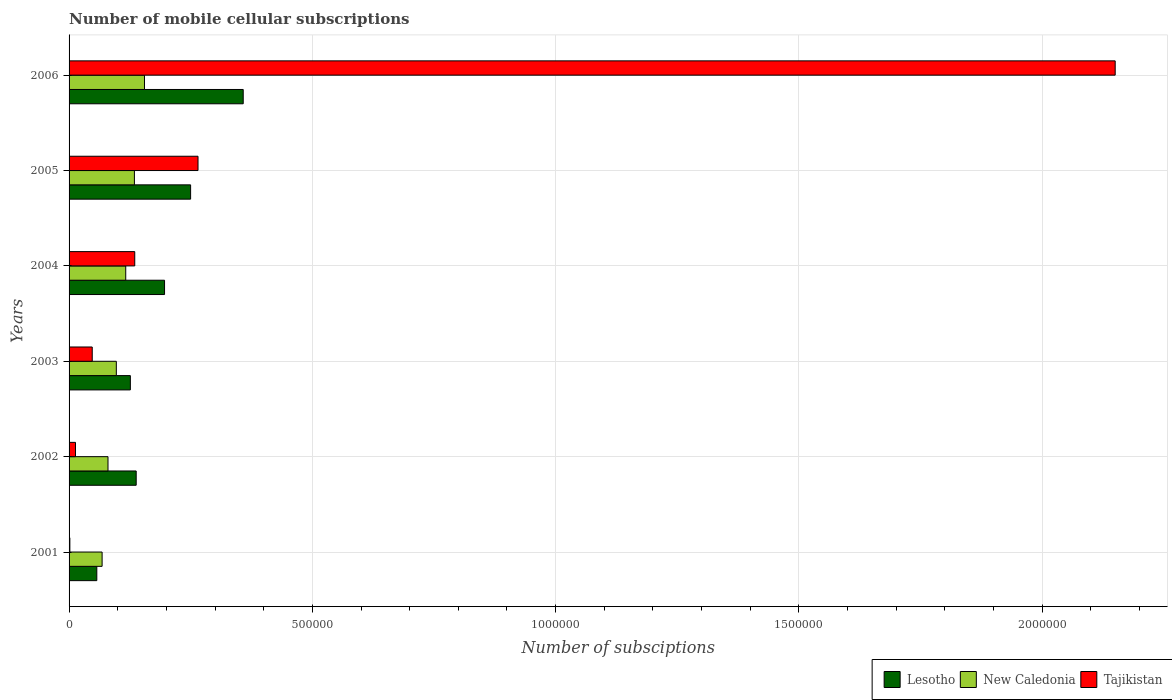How many different coloured bars are there?
Your response must be concise. 3. In how many cases, is the number of bars for a given year not equal to the number of legend labels?
Make the answer very short. 0. What is the number of mobile cellular subscriptions in New Caledonia in 2005?
Provide a succinct answer. 1.34e+05. Across all years, what is the maximum number of mobile cellular subscriptions in Tajikistan?
Provide a short and direct response. 2.15e+06. Across all years, what is the minimum number of mobile cellular subscriptions in Tajikistan?
Provide a short and direct response. 1630. In which year was the number of mobile cellular subscriptions in Tajikistan maximum?
Keep it short and to the point. 2006. What is the total number of mobile cellular subscriptions in Lesotho in the graph?
Keep it short and to the point. 1.12e+06. What is the difference between the number of mobile cellular subscriptions in Tajikistan in 2005 and that in 2006?
Provide a succinct answer. -1.88e+06. What is the difference between the number of mobile cellular subscriptions in New Caledonia in 2003 and the number of mobile cellular subscriptions in Lesotho in 2002?
Give a very brief answer. -4.08e+04. What is the average number of mobile cellular subscriptions in Tajikistan per year?
Your answer should be compact. 4.35e+05. In the year 2006, what is the difference between the number of mobile cellular subscriptions in Tajikistan and number of mobile cellular subscriptions in New Caledonia?
Provide a short and direct response. 2.00e+06. What is the ratio of the number of mobile cellular subscriptions in Lesotho in 2001 to that in 2002?
Keep it short and to the point. 0.41. Is the number of mobile cellular subscriptions in New Caledonia in 2002 less than that in 2004?
Ensure brevity in your answer.  Yes. What is the difference between the highest and the second highest number of mobile cellular subscriptions in Lesotho?
Make the answer very short. 1.08e+05. What is the difference between the highest and the lowest number of mobile cellular subscriptions in Tajikistan?
Offer a terse response. 2.15e+06. In how many years, is the number of mobile cellular subscriptions in New Caledonia greater than the average number of mobile cellular subscriptions in New Caledonia taken over all years?
Your response must be concise. 3. Is the sum of the number of mobile cellular subscriptions in Lesotho in 2002 and 2004 greater than the maximum number of mobile cellular subscriptions in Tajikistan across all years?
Keep it short and to the point. No. What does the 1st bar from the top in 2006 represents?
Your answer should be very brief. Tajikistan. What does the 1st bar from the bottom in 2002 represents?
Offer a terse response. Lesotho. Is it the case that in every year, the sum of the number of mobile cellular subscriptions in Lesotho and number of mobile cellular subscriptions in New Caledonia is greater than the number of mobile cellular subscriptions in Tajikistan?
Ensure brevity in your answer.  No. How many bars are there?
Your response must be concise. 18. How many years are there in the graph?
Provide a short and direct response. 6. What is the difference between two consecutive major ticks on the X-axis?
Provide a succinct answer. 5.00e+05. Does the graph contain any zero values?
Ensure brevity in your answer.  No. How many legend labels are there?
Provide a short and direct response. 3. How are the legend labels stacked?
Your response must be concise. Horizontal. What is the title of the graph?
Provide a succinct answer. Number of mobile cellular subscriptions. What is the label or title of the X-axis?
Make the answer very short. Number of subsciptions. What is the Number of subsciptions in Lesotho in 2001?
Keep it short and to the point. 5.70e+04. What is the Number of subsciptions in New Caledonia in 2001?
Your answer should be very brief. 6.79e+04. What is the Number of subsciptions in Tajikistan in 2001?
Your answer should be very brief. 1630. What is the Number of subsciptions in Lesotho in 2002?
Give a very brief answer. 1.38e+05. What is the Number of subsciptions of Tajikistan in 2002?
Ensure brevity in your answer.  1.32e+04. What is the Number of subsciptions in Lesotho in 2003?
Keep it short and to the point. 1.26e+05. What is the Number of subsciptions of New Caledonia in 2003?
Your answer should be very brief. 9.71e+04. What is the Number of subsciptions of Tajikistan in 2003?
Your response must be concise. 4.76e+04. What is the Number of subsciptions in Lesotho in 2004?
Provide a short and direct response. 1.96e+05. What is the Number of subsciptions of New Caledonia in 2004?
Your answer should be compact. 1.16e+05. What is the Number of subsciptions in Tajikistan in 2004?
Make the answer very short. 1.35e+05. What is the Number of subsciptions of Lesotho in 2005?
Provide a short and direct response. 2.50e+05. What is the Number of subsciptions of New Caledonia in 2005?
Ensure brevity in your answer.  1.34e+05. What is the Number of subsciptions of Tajikistan in 2005?
Ensure brevity in your answer.  2.65e+05. What is the Number of subsciptions of Lesotho in 2006?
Offer a very short reply. 3.58e+05. What is the Number of subsciptions in New Caledonia in 2006?
Your answer should be compact. 1.55e+05. What is the Number of subsciptions in Tajikistan in 2006?
Offer a very short reply. 2.15e+06. Across all years, what is the maximum Number of subsciptions in Lesotho?
Give a very brief answer. 3.58e+05. Across all years, what is the maximum Number of subsciptions in New Caledonia?
Make the answer very short. 1.55e+05. Across all years, what is the maximum Number of subsciptions of Tajikistan?
Your response must be concise. 2.15e+06. Across all years, what is the minimum Number of subsciptions in Lesotho?
Provide a succinct answer. 5.70e+04. Across all years, what is the minimum Number of subsciptions of New Caledonia?
Provide a succinct answer. 6.79e+04. Across all years, what is the minimum Number of subsciptions of Tajikistan?
Provide a short and direct response. 1630. What is the total Number of subsciptions in Lesotho in the graph?
Provide a short and direct response. 1.12e+06. What is the total Number of subsciptions of New Caledonia in the graph?
Keep it short and to the point. 6.51e+05. What is the total Number of subsciptions in Tajikistan in the graph?
Offer a very short reply. 2.61e+06. What is the difference between the Number of subsciptions in Lesotho in 2001 and that in 2002?
Offer a terse response. -8.10e+04. What is the difference between the Number of subsciptions of New Caledonia in 2001 and that in 2002?
Offer a very short reply. -1.21e+04. What is the difference between the Number of subsciptions of Tajikistan in 2001 and that in 2002?
Keep it short and to the point. -1.16e+04. What is the difference between the Number of subsciptions in Lesotho in 2001 and that in 2003?
Give a very brief answer. -6.90e+04. What is the difference between the Number of subsciptions in New Caledonia in 2001 and that in 2003?
Ensure brevity in your answer.  -2.92e+04. What is the difference between the Number of subsciptions of Tajikistan in 2001 and that in 2003?
Your answer should be compact. -4.60e+04. What is the difference between the Number of subsciptions in Lesotho in 2001 and that in 2004?
Your response must be concise. -1.39e+05. What is the difference between the Number of subsciptions of New Caledonia in 2001 and that in 2004?
Provide a succinct answer. -4.85e+04. What is the difference between the Number of subsciptions of Tajikistan in 2001 and that in 2004?
Your answer should be compact. -1.33e+05. What is the difference between the Number of subsciptions in Lesotho in 2001 and that in 2005?
Offer a very short reply. -1.93e+05. What is the difference between the Number of subsciptions of New Caledonia in 2001 and that in 2005?
Offer a very short reply. -6.63e+04. What is the difference between the Number of subsciptions in Tajikistan in 2001 and that in 2005?
Your answer should be very brief. -2.63e+05. What is the difference between the Number of subsciptions of Lesotho in 2001 and that in 2006?
Keep it short and to the point. -3.01e+05. What is the difference between the Number of subsciptions of New Caledonia in 2001 and that in 2006?
Provide a succinct answer. -8.71e+04. What is the difference between the Number of subsciptions of Tajikistan in 2001 and that in 2006?
Ensure brevity in your answer.  -2.15e+06. What is the difference between the Number of subsciptions in Lesotho in 2002 and that in 2003?
Offer a very short reply. 1.20e+04. What is the difference between the Number of subsciptions in New Caledonia in 2002 and that in 2003?
Make the answer very short. -1.71e+04. What is the difference between the Number of subsciptions of Tajikistan in 2002 and that in 2003?
Your answer should be compact. -3.44e+04. What is the difference between the Number of subsciptions in Lesotho in 2002 and that in 2004?
Provide a short and direct response. -5.83e+04. What is the difference between the Number of subsciptions of New Caledonia in 2002 and that in 2004?
Provide a short and direct response. -3.64e+04. What is the difference between the Number of subsciptions in Tajikistan in 2002 and that in 2004?
Your response must be concise. -1.22e+05. What is the difference between the Number of subsciptions of Lesotho in 2002 and that in 2005?
Provide a succinct answer. -1.12e+05. What is the difference between the Number of subsciptions in New Caledonia in 2002 and that in 2005?
Your response must be concise. -5.43e+04. What is the difference between the Number of subsciptions in Tajikistan in 2002 and that in 2005?
Provide a succinct answer. -2.52e+05. What is the difference between the Number of subsciptions in Lesotho in 2002 and that in 2006?
Your answer should be very brief. -2.20e+05. What is the difference between the Number of subsciptions of New Caledonia in 2002 and that in 2006?
Make the answer very short. -7.50e+04. What is the difference between the Number of subsciptions of Tajikistan in 2002 and that in 2006?
Your answer should be very brief. -2.14e+06. What is the difference between the Number of subsciptions of Lesotho in 2003 and that in 2004?
Your response must be concise. -7.03e+04. What is the difference between the Number of subsciptions of New Caledonia in 2003 and that in 2004?
Your answer should be very brief. -1.93e+04. What is the difference between the Number of subsciptions of Tajikistan in 2003 and that in 2004?
Offer a terse response. -8.74e+04. What is the difference between the Number of subsciptions in Lesotho in 2003 and that in 2005?
Your response must be concise. -1.24e+05. What is the difference between the Number of subsciptions of New Caledonia in 2003 and that in 2005?
Keep it short and to the point. -3.72e+04. What is the difference between the Number of subsciptions of Tajikistan in 2003 and that in 2005?
Provide a succinct answer. -2.17e+05. What is the difference between the Number of subsciptions in Lesotho in 2003 and that in 2006?
Your response must be concise. -2.32e+05. What is the difference between the Number of subsciptions of New Caledonia in 2003 and that in 2006?
Offer a terse response. -5.79e+04. What is the difference between the Number of subsciptions of Tajikistan in 2003 and that in 2006?
Your answer should be compact. -2.10e+06. What is the difference between the Number of subsciptions of Lesotho in 2004 and that in 2005?
Ensure brevity in your answer.  -5.36e+04. What is the difference between the Number of subsciptions of New Caledonia in 2004 and that in 2005?
Your response must be concise. -1.78e+04. What is the difference between the Number of subsciptions in Lesotho in 2004 and that in 2006?
Your answer should be very brief. -1.62e+05. What is the difference between the Number of subsciptions of New Caledonia in 2004 and that in 2006?
Your response must be concise. -3.86e+04. What is the difference between the Number of subsciptions in Tajikistan in 2004 and that in 2006?
Give a very brief answer. -2.02e+06. What is the difference between the Number of subsciptions of Lesotho in 2005 and that in 2006?
Keep it short and to the point. -1.08e+05. What is the difference between the Number of subsciptions of New Caledonia in 2005 and that in 2006?
Provide a succinct answer. -2.07e+04. What is the difference between the Number of subsciptions of Tajikistan in 2005 and that in 2006?
Provide a short and direct response. -1.88e+06. What is the difference between the Number of subsciptions in Lesotho in 2001 and the Number of subsciptions in New Caledonia in 2002?
Keep it short and to the point. -2.30e+04. What is the difference between the Number of subsciptions in Lesotho in 2001 and the Number of subsciptions in Tajikistan in 2002?
Ensure brevity in your answer.  4.38e+04. What is the difference between the Number of subsciptions in New Caledonia in 2001 and the Number of subsciptions in Tajikistan in 2002?
Your answer should be very brief. 5.47e+04. What is the difference between the Number of subsciptions of Lesotho in 2001 and the Number of subsciptions of New Caledonia in 2003?
Your answer should be compact. -4.01e+04. What is the difference between the Number of subsciptions of Lesotho in 2001 and the Number of subsciptions of Tajikistan in 2003?
Offer a very short reply. 9383. What is the difference between the Number of subsciptions in New Caledonia in 2001 and the Number of subsciptions in Tajikistan in 2003?
Ensure brevity in your answer.  2.03e+04. What is the difference between the Number of subsciptions of Lesotho in 2001 and the Number of subsciptions of New Caledonia in 2004?
Your answer should be very brief. -5.94e+04. What is the difference between the Number of subsciptions of Lesotho in 2001 and the Number of subsciptions of Tajikistan in 2004?
Give a very brief answer. -7.80e+04. What is the difference between the Number of subsciptions of New Caledonia in 2001 and the Number of subsciptions of Tajikistan in 2004?
Give a very brief answer. -6.71e+04. What is the difference between the Number of subsciptions of Lesotho in 2001 and the Number of subsciptions of New Caledonia in 2005?
Keep it short and to the point. -7.73e+04. What is the difference between the Number of subsciptions of Lesotho in 2001 and the Number of subsciptions of Tajikistan in 2005?
Give a very brief answer. -2.08e+05. What is the difference between the Number of subsciptions of New Caledonia in 2001 and the Number of subsciptions of Tajikistan in 2005?
Ensure brevity in your answer.  -1.97e+05. What is the difference between the Number of subsciptions of Lesotho in 2001 and the Number of subsciptions of New Caledonia in 2006?
Ensure brevity in your answer.  -9.80e+04. What is the difference between the Number of subsciptions of Lesotho in 2001 and the Number of subsciptions of Tajikistan in 2006?
Make the answer very short. -2.09e+06. What is the difference between the Number of subsciptions of New Caledonia in 2001 and the Number of subsciptions of Tajikistan in 2006?
Provide a succinct answer. -2.08e+06. What is the difference between the Number of subsciptions of Lesotho in 2002 and the Number of subsciptions of New Caledonia in 2003?
Your response must be concise. 4.08e+04. What is the difference between the Number of subsciptions of Lesotho in 2002 and the Number of subsciptions of Tajikistan in 2003?
Keep it short and to the point. 9.03e+04. What is the difference between the Number of subsciptions in New Caledonia in 2002 and the Number of subsciptions in Tajikistan in 2003?
Provide a succinct answer. 3.24e+04. What is the difference between the Number of subsciptions in Lesotho in 2002 and the Number of subsciptions in New Caledonia in 2004?
Keep it short and to the point. 2.15e+04. What is the difference between the Number of subsciptions in Lesotho in 2002 and the Number of subsciptions in Tajikistan in 2004?
Offer a terse response. 2953. What is the difference between the Number of subsciptions of New Caledonia in 2002 and the Number of subsciptions of Tajikistan in 2004?
Give a very brief answer. -5.50e+04. What is the difference between the Number of subsciptions of Lesotho in 2002 and the Number of subsciptions of New Caledonia in 2005?
Provide a short and direct response. 3688. What is the difference between the Number of subsciptions of Lesotho in 2002 and the Number of subsciptions of Tajikistan in 2005?
Ensure brevity in your answer.  -1.27e+05. What is the difference between the Number of subsciptions in New Caledonia in 2002 and the Number of subsciptions in Tajikistan in 2005?
Your answer should be very brief. -1.85e+05. What is the difference between the Number of subsciptions in Lesotho in 2002 and the Number of subsciptions in New Caledonia in 2006?
Give a very brief answer. -1.70e+04. What is the difference between the Number of subsciptions of Lesotho in 2002 and the Number of subsciptions of Tajikistan in 2006?
Give a very brief answer. -2.01e+06. What is the difference between the Number of subsciptions in New Caledonia in 2002 and the Number of subsciptions in Tajikistan in 2006?
Provide a short and direct response. -2.07e+06. What is the difference between the Number of subsciptions of Lesotho in 2003 and the Number of subsciptions of New Caledonia in 2004?
Your answer should be very brief. 9507. What is the difference between the Number of subsciptions in Lesotho in 2003 and the Number of subsciptions in Tajikistan in 2004?
Make the answer very short. -9050. What is the difference between the Number of subsciptions of New Caledonia in 2003 and the Number of subsciptions of Tajikistan in 2004?
Keep it short and to the point. -3.79e+04. What is the difference between the Number of subsciptions in Lesotho in 2003 and the Number of subsciptions in New Caledonia in 2005?
Give a very brief answer. -8315. What is the difference between the Number of subsciptions in Lesotho in 2003 and the Number of subsciptions in Tajikistan in 2005?
Your answer should be very brief. -1.39e+05. What is the difference between the Number of subsciptions of New Caledonia in 2003 and the Number of subsciptions of Tajikistan in 2005?
Make the answer very short. -1.68e+05. What is the difference between the Number of subsciptions of Lesotho in 2003 and the Number of subsciptions of New Caledonia in 2006?
Provide a short and direct response. -2.90e+04. What is the difference between the Number of subsciptions of Lesotho in 2003 and the Number of subsciptions of Tajikistan in 2006?
Ensure brevity in your answer.  -2.02e+06. What is the difference between the Number of subsciptions in New Caledonia in 2003 and the Number of subsciptions in Tajikistan in 2006?
Ensure brevity in your answer.  -2.05e+06. What is the difference between the Number of subsciptions of Lesotho in 2004 and the Number of subsciptions of New Caledonia in 2005?
Your answer should be very brief. 6.19e+04. What is the difference between the Number of subsciptions in Lesotho in 2004 and the Number of subsciptions in Tajikistan in 2005?
Your answer should be very brief. -6.88e+04. What is the difference between the Number of subsciptions of New Caledonia in 2004 and the Number of subsciptions of Tajikistan in 2005?
Give a very brief answer. -1.49e+05. What is the difference between the Number of subsciptions in Lesotho in 2004 and the Number of subsciptions in New Caledonia in 2006?
Provide a succinct answer. 4.12e+04. What is the difference between the Number of subsciptions of Lesotho in 2004 and the Number of subsciptions of Tajikistan in 2006?
Offer a very short reply. -1.95e+06. What is the difference between the Number of subsciptions of New Caledonia in 2004 and the Number of subsciptions of Tajikistan in 2006?
Offer a very short reply. -2.03e+06. What is the difference between the Number of subsciptions of Lesotho in 2005 and the Number of subsciptions of New Caledonia in 2006?
Your answer should be compact. 9.48e+04. What is the difference between the Number of subsciptions of Lesotho in 2005 and the Number of subsciptions of Tajikistan in 2006?
Make the answer very short. -1.90e+06. What is the difference between the Number of subsciptions of New Caledonia in 2005 and the Number of subsciptions of Tajikistan in 2006?
Offer a very short reply. -2.02e+06. What is the average Number of subsciptions in Lesotho per year?
Offer a terse response. 1.87e+05. What is the average Number of subsciptions of New Caledonia per year?
Your answer should be compact. 1.08e+05. What is the average Number of subsciptions of Tajikistan per year?
Your answer should be compact. 4.35e+05. In the year 2001, what is the difference between the Number of subsciptions of Lesotho and Number of subsciptions of New Caledonia?
Offer a very short reply. -1.09e+04. In the year 2001, what is the difference between the Number of subsciptions of Lesotho and Number of subsciptions of Tajikistan?
Keep it short and to the point. 5.54e+04. In the year 2001, what is the difference between the Number of subsciptions in New Caledonia and Number of subsciptions in Tajikistan?
Offer a very short reply. 6.63e+04. In the year 2002, what is the difference between the Number of subsciptions in Lesotho and Number of subsciptions in New Caledonia?
Offer a terse response. 5.80e+04. In the year 2002, what is the difference between the Number of subsciptions in Lesotho and Number of subsciptions in Tajikistan?
Ensure brevity in your answer.  1.25e+05. In the year 2002, what is the difference between the Number of subsciptions of New Caledonia and Number of subsciptions of Tajikistan?
Make the answer very short. 6.68e+04. In the year 2003, what is the difference between the Number of subsciptions of Lesotho and Number of subsciptions of New Caledonia?
Offer a terse response. 2.88e+04. In the year 2003, what is the difference between the Number of subsciptions of Lesotho and Number of subsciptions of Tajikistan?
Make the answer very short. 7.83e+04. In the year 2003, what is the difference between the Number of subsciptions in New Caledonia and Number of subsciptions in Tajikistan?
Provide a short and direct response. 4.95e+04. In the year 2004, what is the difference between the Number of subsciptions in Lesotho and Number of subsciptions in New Caledonia?
Keep it short and to the point. 7.98e+04. In the year 2004, what is the difference between the Number of subsciptions in Lesotho and Number of subsciptions in Tajikistan?
Your answer should be very brief. 6.12e+04. In the year 2004, what is the difference between the Number of subsciptions of New Caledonia and Number of subsciptions of Tajikistan?
Your answer should be very brief. -1.86e+04. In the year 2005, what is the difference between the Number of subsciptions of Lesotho and Number of subsciptions of New Caledonia?
Make the answer very short. 1.16e+05. In the year 2005, what is the difference between the Number of subsciptions of Lesotho and Number of subsciptions of Tajikistan?
Your response must be concise. -1.52e+04. In the year 2005, what is the difference between the Number of subsciptions in New Caledonia and Number of subsciptions in Tajikistan?
Keep it short and to the point. -1.31e+05. In the year 2006, what is the difference between the Number of subsciptions in Lesotho and Number of subsciptions in New Caledonia?
Provide a succinct answer. 2.03e+05. In the year 2006, what is the difference between the Number of subsciptions of Lesotho and Number of subsciptions of Tajikistan?
Provide a succinct answer. -1.79e+06. In the year 2006, what is the difference between the Number of subsciptions in New Caledonia and Number of subsciptions in Tajikistan?
Provide a succinct answer. -2.00e+06. What is the ratio of the Number of subsciptions in Lesotho in 2001 to that in 2002?
Provide a short and direct response. 0.41. What is the ratio of the Number of subsciptions of New Caledonia in 2001 to that in 2002?
Make the answer very short. 0.85. What is the ratio of the Number of subsciptions of Tajikistan in 2001 to that in 2002?
Offer a very short reply. 0.12. What is the ratio of the Number of subsciptions of Lesotho in 2001 to that in 2003?
Your answer should be compact. 0.45. What is the ratio of the Number of subsciptions of New Caledonia in 2001 to that in 2003?
Your answer should be compact. 0.7. What is the ratio of the Number of subsciptions of Tajikistan in 2001 to that in 2003?
Your answer should be compact. 0.03. What is the ratio of the Number of subsciptions of Lesotho in 2001 to that in 2004?
Give a very brief answer. 0.29. What is the ratio of the Number of subsciptions of New Caledonia in 2001 to that in 2004?
Provide a succinct answer. 0.58. What is the ratio of the Number of subsciptions of Tajikistan in 2001 to that in 2004?
Your answer should be compact. 0.01. What is the ratio of the Number of subsciptions in Lesotho in 2001 to that in 2005?
Offer a terse response. 0.23. What is the ratio of the Number of subsciptions of New Caledonia in 2001 to that in 2005?
Your answer should be compact. 0.51. What is the ratio of the Number of subsciptions in Tajikistan in 2001 to that in 2005?
Offer a very short reply. 0.01. What is the ratio of the Number of subsciptions of Lesotho in 2001 to that in 2006?
Provide a succinct answer. 0.16. What is the ratio of the Number of subsciptions in New Caledonia in 2001 to that in 2006?
Your answer should be very brief. 0.44. What is the ratio of the Number of subsciptions in Tajikistan in 2001 to that in 2006?
Keep it short and to the point. 0. What is the ratio of the Number of subsciptions of Lesotho in 2002 to that in 2003?
Offer a terse response. 1.1. What is the ratio of the Number of subsciptions in New Caledonia in 2002 to that in 2003?
Make the answer very short. 0.82. What is the ratio of the Number of subsciptions in Tajikistan in 2002 to that in 2003?
Your answer should be very brief. 0.28. What is the ratio of the Number of subsciptions of Lesotho in 2002 to that in 2004?
Provide a succinct answer. 0.7. What is the ratio of the Number of subsciptions in New Caledonia in 2002 to that in 2004?
Keep it short and to the point. 0.69. What is the ratio of the Number of subsciptions in Tajikistan in 2002 to that in 2004?
Provide a succinct answer. 0.1. What is the ratio of the Number of subsciptions in Lesotho in 2002 to that in 2005?
Your answer should be very brief. 0.55. What is the ratio of the Number of subsciptions of New Caledonia in 2002 to that in 2005?
Provide a short and direct response. 0.6. What is the ratio of the Number of subsciptions of Tajikistan in 2002 to that in 2005?
Make the answer very short. 0.05. What is the ratio of the Number of subsciptions in Lesotho in 2002 to that in 2006?
Keep it short and to the point. 0.39. What is the ratio of the Number of subsciptions in New Caledonia in 2002 to that in 2006?
Your answer should be compact. 0.52. What is the ratio of the Number of subsciptions in Tajikistan in 2002 to that in 2006?
Keep it short and to the point. 0.01. What is the ratio of the Number of subsciptions of Lesotho in 2003 to that in 2004?
Keep it short and to the point. 0.64. What is the ratio of the Number of subsciptions in New Caledonia in 2003 to that in 2004?
Provide a succinct answer. 0.83. What is the ratio of the Number of subsciptions of Tajikistan in 2003 to that in 2004?
Ensure brevity in your answer.  0.35. What is the ratio of the Number of subsciptions in Lesotho in 2003 to that in 2005?
Ensure brevity in your answer.  0.5. What is the ratio of the Number of subsciptions of New Caledonia in 2003 to that in 2005?
Your answer should be very brief. 0.72. What is the ratio of the Number of subsciptions in Tajikistan in 2003 to that in 2005?
Offer a very short reply. 0.18. What is the ratio of the Number of subsciptions in Lesotho in 2003 to that in 2006?
Ensure brevity in your answer.  0.35. What is the ratio of the Number of subsciptions in New Caledonia in 2003 to that in 2006?
Offer a terse response. 0.63. What is the ratio of the Number of subsciptions in Tajikistan in 2003 to that in 2006?
Your answer should be very brief. 0.02. What is the ratio of the Number of subsciptions of Lesotho in 2004 to that in 2005?
Offer a terse response. 0.79. What is the ratio of the Number of subsciptions in New Caledonia in 2004 to that in 2005?
Your response must be concise. 0.87. What is the ratio of the Number of subsciptions in Tajikistan in 2004 to that in 2005?
Keep it short and to the point. 0.51. What is the ratio of the Number of subsciptions of Lesotho in 2004 to that in 2006?
Make the answer very short. 0.55. What is the ratio of the Number of subsciptions in New Caledonia in 2004 to that in 2006?
Keep it short and to the point. 0.75. What is the ratio of the Number of subsciptions in Tajikistan in 2004 to that in 2006?
Offer a very short reply. 0.06. What is the ratio of the Number of subsciptions in Lesotho in 2005 to that in 2006?
Keep it short and to the point. 0.7. What is the ratio of the Number of subsciptions of New Caledonia in 2005 to that in 2006?
Offer a very short reply. 0.87. What is the ratio of the Number of subsciptions of Tajikistan in 2005 to that in 2006?
Offer a terse response. 0.12. What is the difference between the highest and the second highest Number of subsciptions of Lesotho?
Ensure brevity in your answer.  1.08e+05. What is the difference between the highest and the second highest Number of subsciptions in New Caledonia?
Offer a terse response. 2.07e+04. What is the difference between the highest and the second highest Number of subsciptions of Tajikistan?
Your answer should be very brief. 1.88e+06. What is the difference between the highest and the lowest Number of subsciptions in Lesotho?
Your answer should be compact. 3.01e+05. What is the difference between the highest and the lowest Number of subsciptions in New Caledonia?
Provide a succinct answer. 8.71e+04. What is the difference between the highest and the lowest Number of subsciptions in Tajikistan?
Your response must be concise. 2.15e+06. 